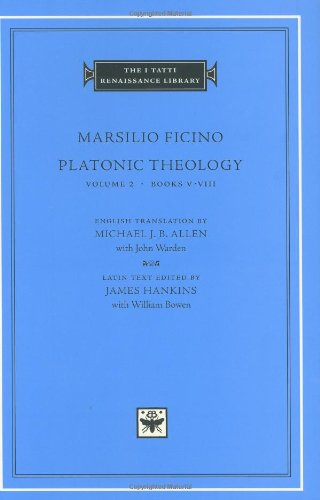Who wrote this book? The book displayed in the image, 'Platonic Theology,' was authored by Marsilio Ficino, a notable figure of the Italian Renaissance who played a foundational role in the revival of Platonic philosophy. 